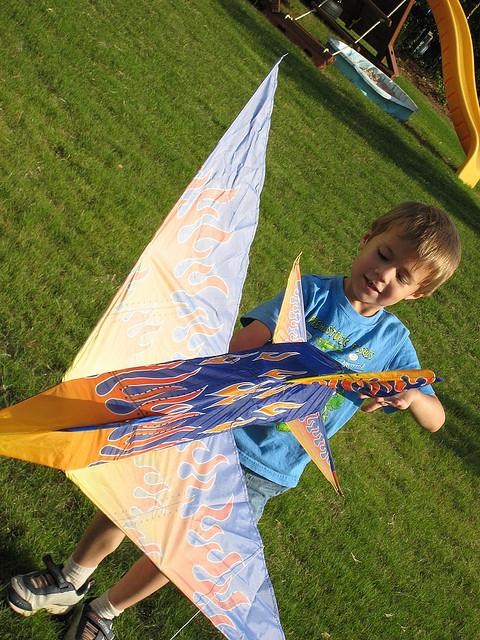What is the kid holding?
Short answer required. Kite. Does the kid like to fly kites?
Give a very brief answer. Yes. What color is the child's shirt?
Give a very brief answer. Blue. 